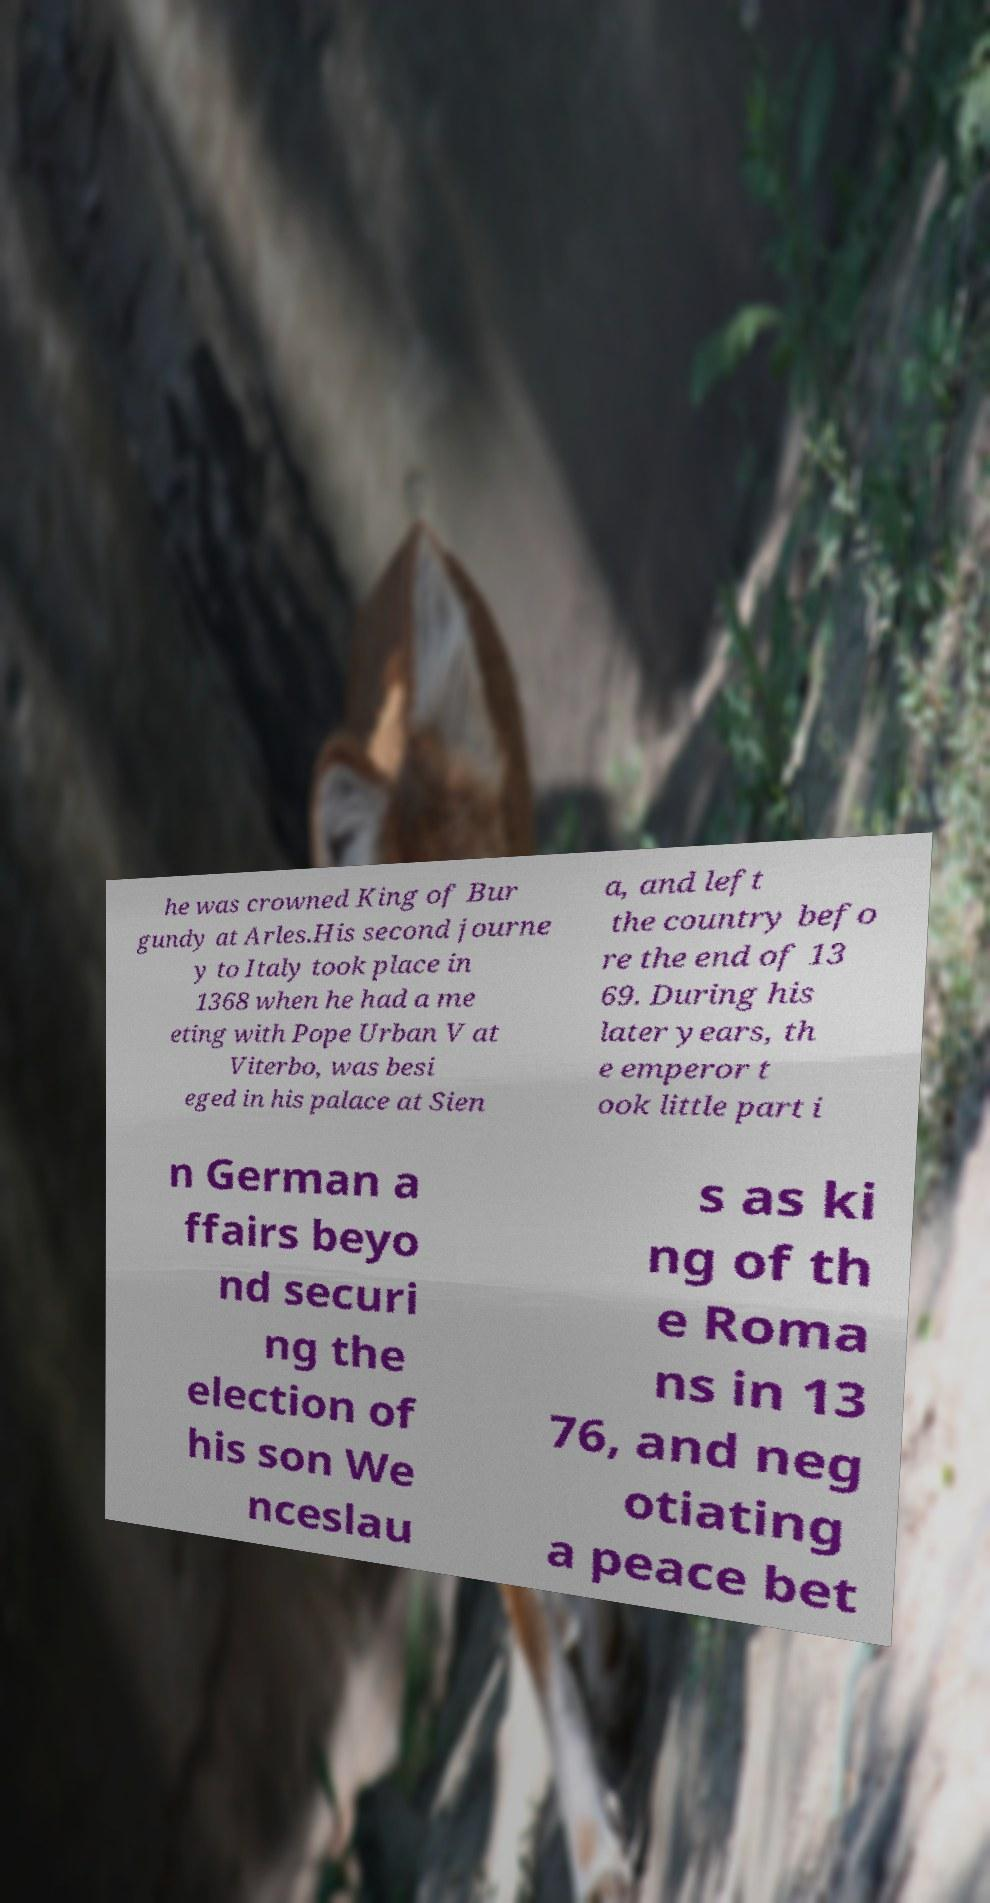Could you assist in decoding the text presented in this image and type it out clearly? he was crowned King of Bur gundy at Arles.His second journe y to Italy took place in 1368 when he had a me eting with Pope Urban V at Viterbo, was besi eged in his palace at Sien a, and left the country befo re the end of 13 69. During his later years, th e emperor t ook little part i n German a ffairs beyo nd securi ng the election of his son We nceslau s as ki ng of th e Roma ns in 13 76, and neg otiating a peace bet 